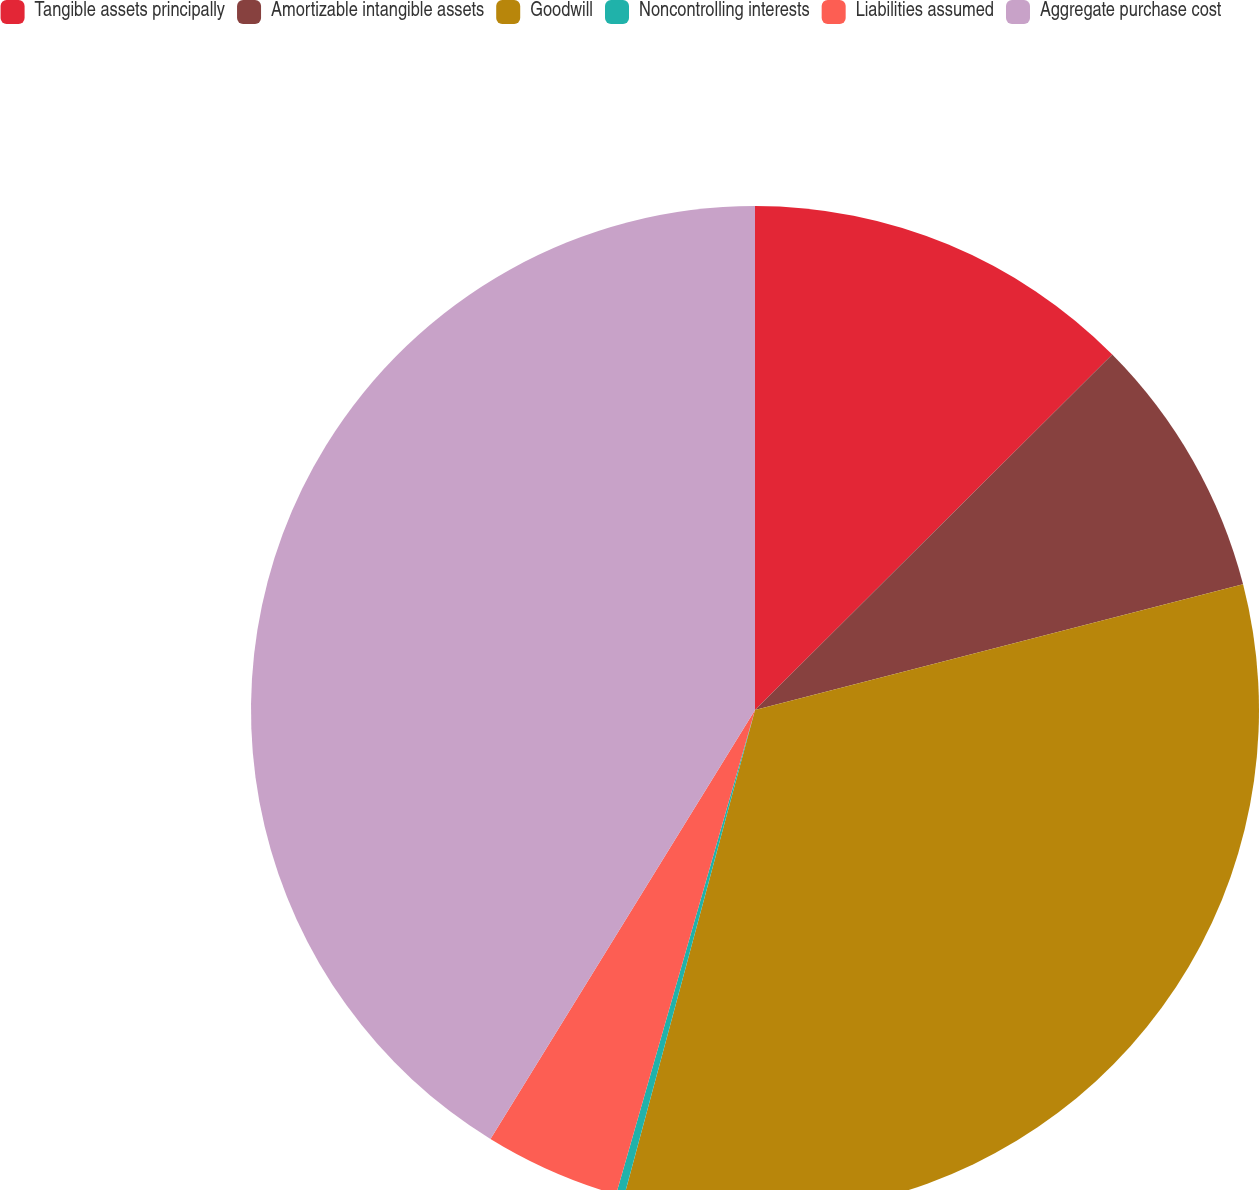<chart> <loc_0><loc_0><loc_500><loc_500><pie_chart><fcel>Tangible assets principally<fcel>Amortizable intangible assets<fcel>Goodwill<fcel>Noncontrolling interests<fcel>Liabilities assumed<fcel>Aggregate purchase cost<nl><fcel>12.54%<fcel>8.45%<fcel>33.2%<fcel>0.26%<fcel>4.35%<fcel>41.21%<nl></chart> 